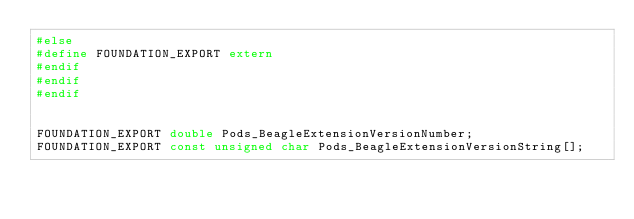<code> <loc_0><loc_0><loc_500><loc_500><_C_>#else
#define FOUNDATION_EXPORT extern
#endif
#endif
#endif


FOUNDATION_EXPORT double Pods_BeagleExtensionVersionNumber;
FOUNDATION_EXPORT const unsigned char Pods_BeagleExtensionVersionString[];

</code> 